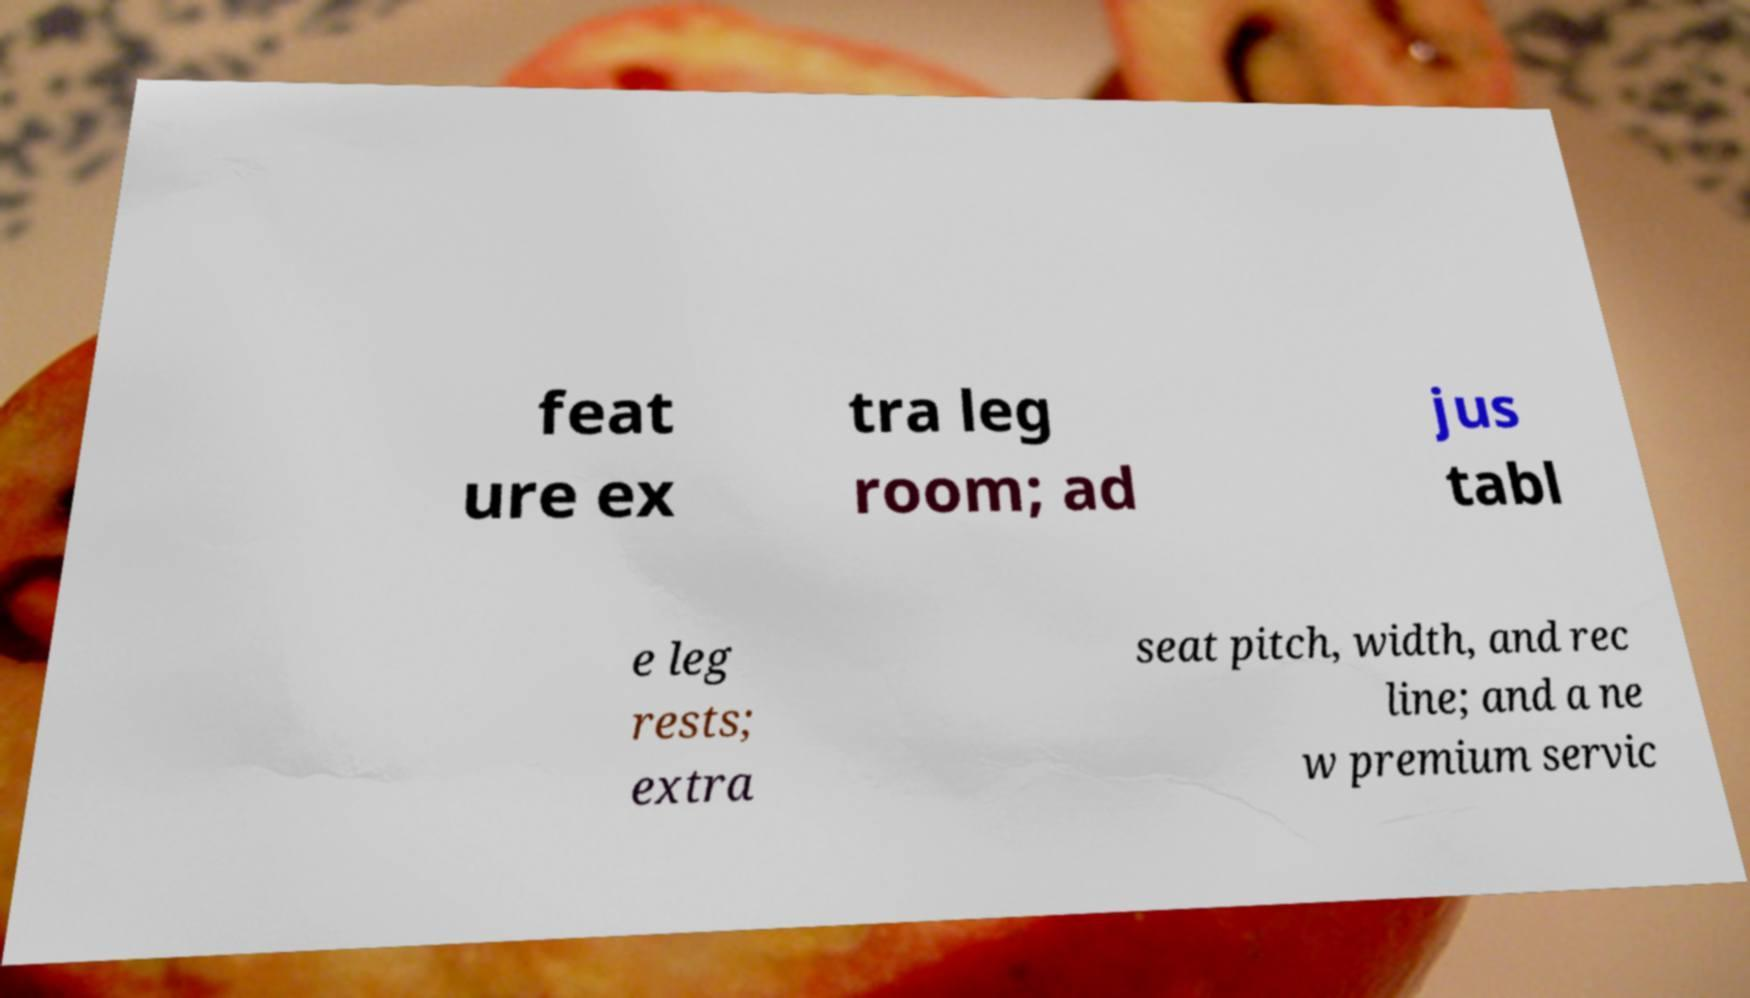Could you extract and type out the text from this image? feat ure ex tra leg room; ad jus tabl e leg rests; extra seat pitch, width, and rec line; and a ne w premium servic 